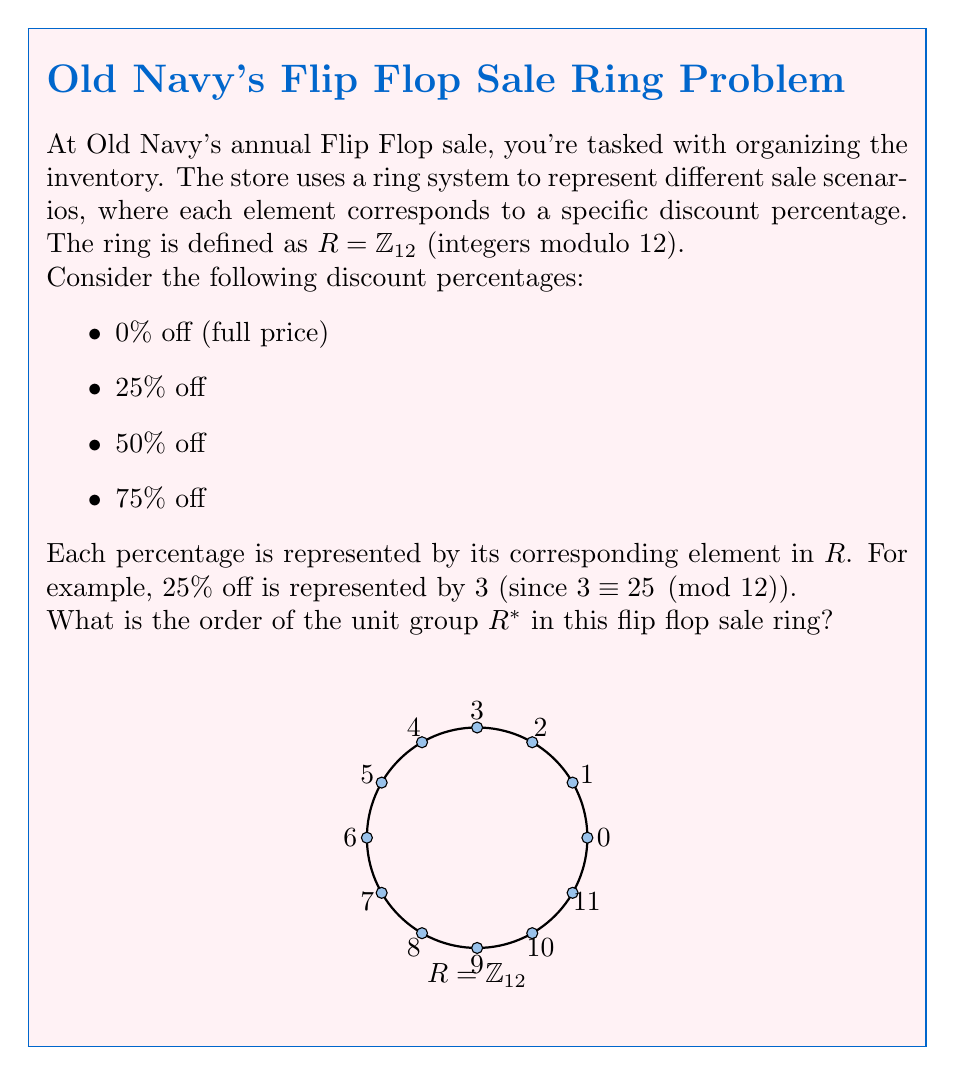Solve this math problem. Let's approach this step-by-step:

1) First, we need to identify the units in $R = \mathbb{Z}_{12}$. A unit is an element that has a multiplicative inverse.

2) In $\mathbb{Z}_{12}$, an element $a$ is a unit if and only if $\gcd(a,12) = 1$.

3) Let's check each element:
   - $\gcd(1,12) = 1$, so 1 is a unit
   - $\gcd(2,12) = 2$, not a unit
   - $\gcd(3,12) = 3$, not a unit
   - $\gcd(4,12) = 4$, not a unit
   - $\gcd(5,12) = 1$, so 5 is a unit
   - $\gcd(6,12) = 6$, not a unit
   - $\gcd(7,12) = 1$, so 7 is a unit
   - $\gcd(8,12) = 4$, not a unit
   - $\gcd(9,12) = 3$, not a unit
   - $\gcd(10,12) = 2$, not a unit
   - $\gcd(11,12) = 1$, so 11 is a unit

4) The units in $\mathbb{Z}_{12}$ are therefore $\{1, 5, 7, 11\}$.

5) The order of the unit group $R^*$ is the number of units in $R$.

6) Therefore, the order of $R^*$ is 4.

In the context of the flip flop sale, this means there are 4 different ways to apply the discount percentages that maintain the ring structure, corresponding to the 4 units in $\mathbb{Z}_{12}$.
Answer: 4 